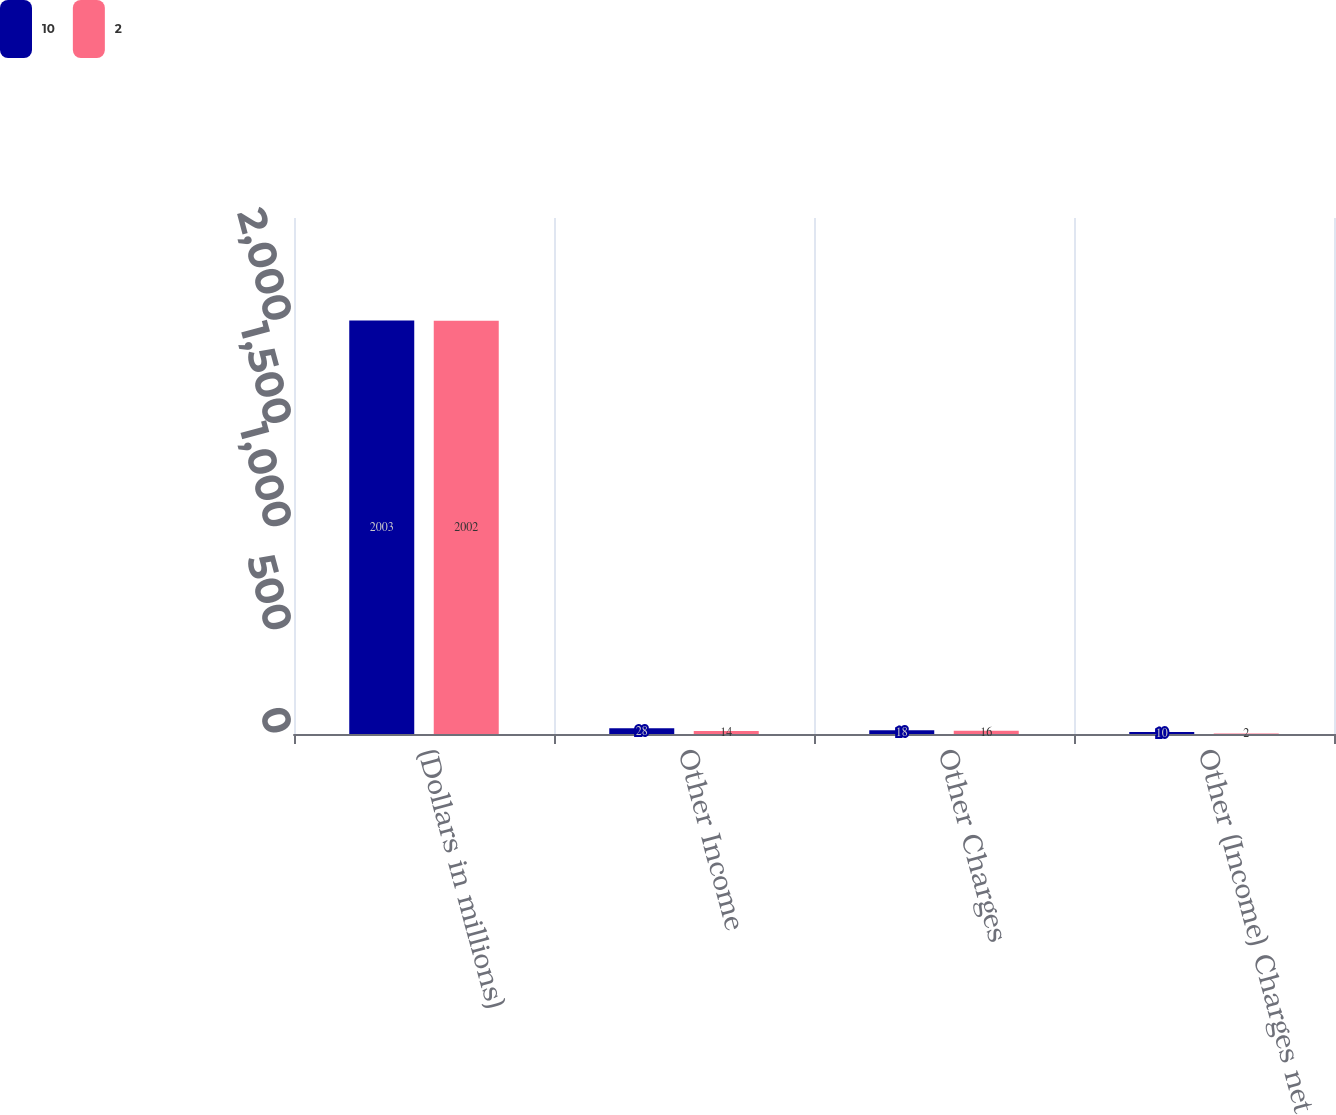Convert chart to OTSL. <chart><loc_0><loc_0><loc_500><loc_500><stacked_bar_chart><ecel><fcel>(Dollars in millions)<fcel>Other Income<fcel>Other Charges<fcel>Other (Income) Charges net<nl><fcel>10<fcel>2003<fcel>28<fcel>18<fcel>10<nl><fcel>2<fcel>2002<fcel>14<fcel>16<fcel>2<nl></chart> 